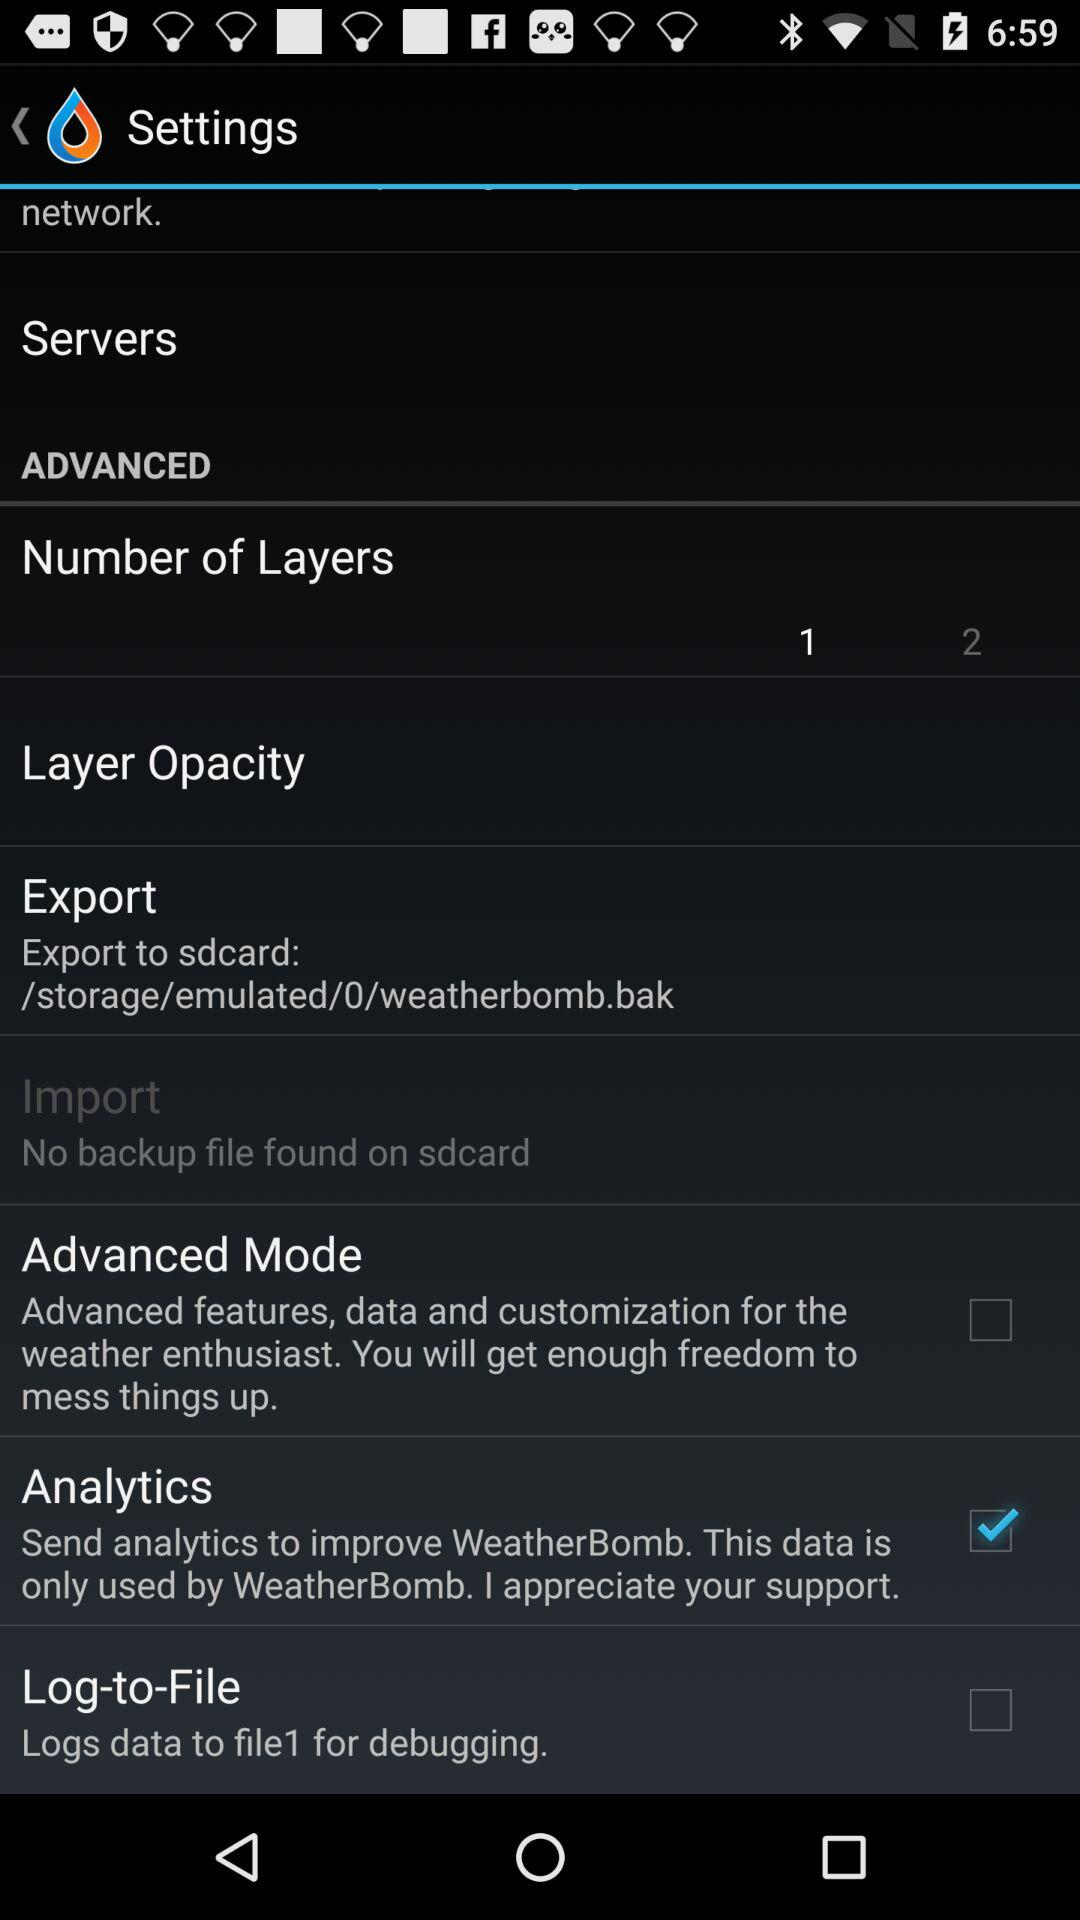What is the status of "Analytics"? The status of "Analytics" is "on". 